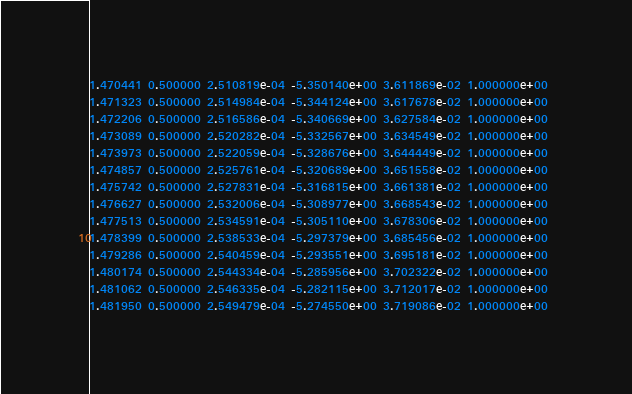Convert code to text. <code><loc_0><loc_0><loc_500><loc_500><_SQL_>1.470441 0.500000 2.510819e-04 -5.350140e+00 3.611869e-02 1.000000e+00 
1.471323 0.500000 2.514984e-04 -5.344124e+00 3.617678e-02 1.000000e+00 
1.472206 0.500000 2.516586e-04 -5.340669e+00 3.627584e-02 1.000000e+00 
1.473089 0.500000 2.520282e-04 -5.332567e+00 3.634549e-02 1.000000e+00 
1.473973 0.500000 2.522059e-04 -5.328676e+00 3.644449e-02 1.000000e+00 
1.474857 0.500000 2.525761e-04 -5.320689e+00 3.651558e-02 1.000000e+00 
1.475742 0.500000 2.527831e-04 -5.316815e+00 3.661381e-02 1.000000e+00 
1.476627 0.500000 2.532006e-04 -5.308977e+00 3.668543e-02 1.000000e+00 
1.477513 0.500000 2.534591e-04 -5.305110e+00 3.678306e-02 1.000000e+00 
1.478399 0.500000 2.538533e-04 -5.297379e+00 3.685456e-02 1.000000e+00 
1.479286 0.500000 2.540459e-04 -5.293551e+00 3.695181e-02 1.000000e+00 
1.480174 0.500000 2.544334e-04 -5.285956e+00 3.702322e-02 1.000000e+00 
1.481062 0.500000 2.546335e-04 -5.282115e+00 3.712017e-02 1.000000e+00 
1.481950 0.500000 2.549479e-04 -5.274550e+00 3.719086e-02 1.000000e+00 </code> 